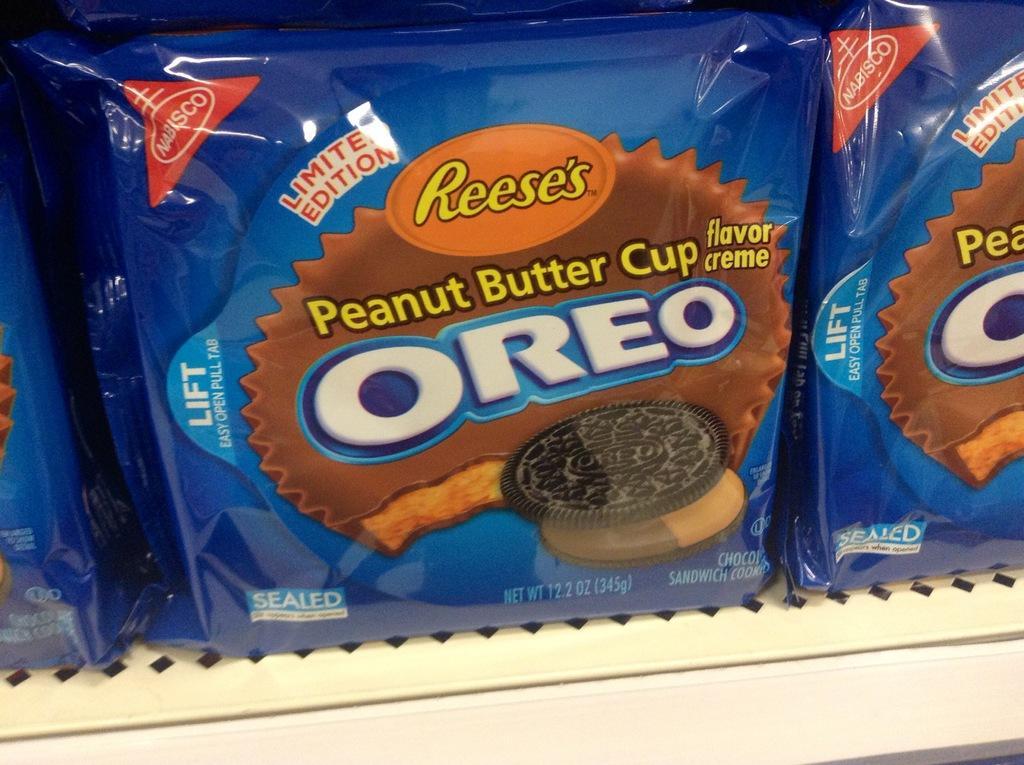Please provide a concise description of this image. In this image we can see a biscuit packet written Oreo on it is placed in a rack. 